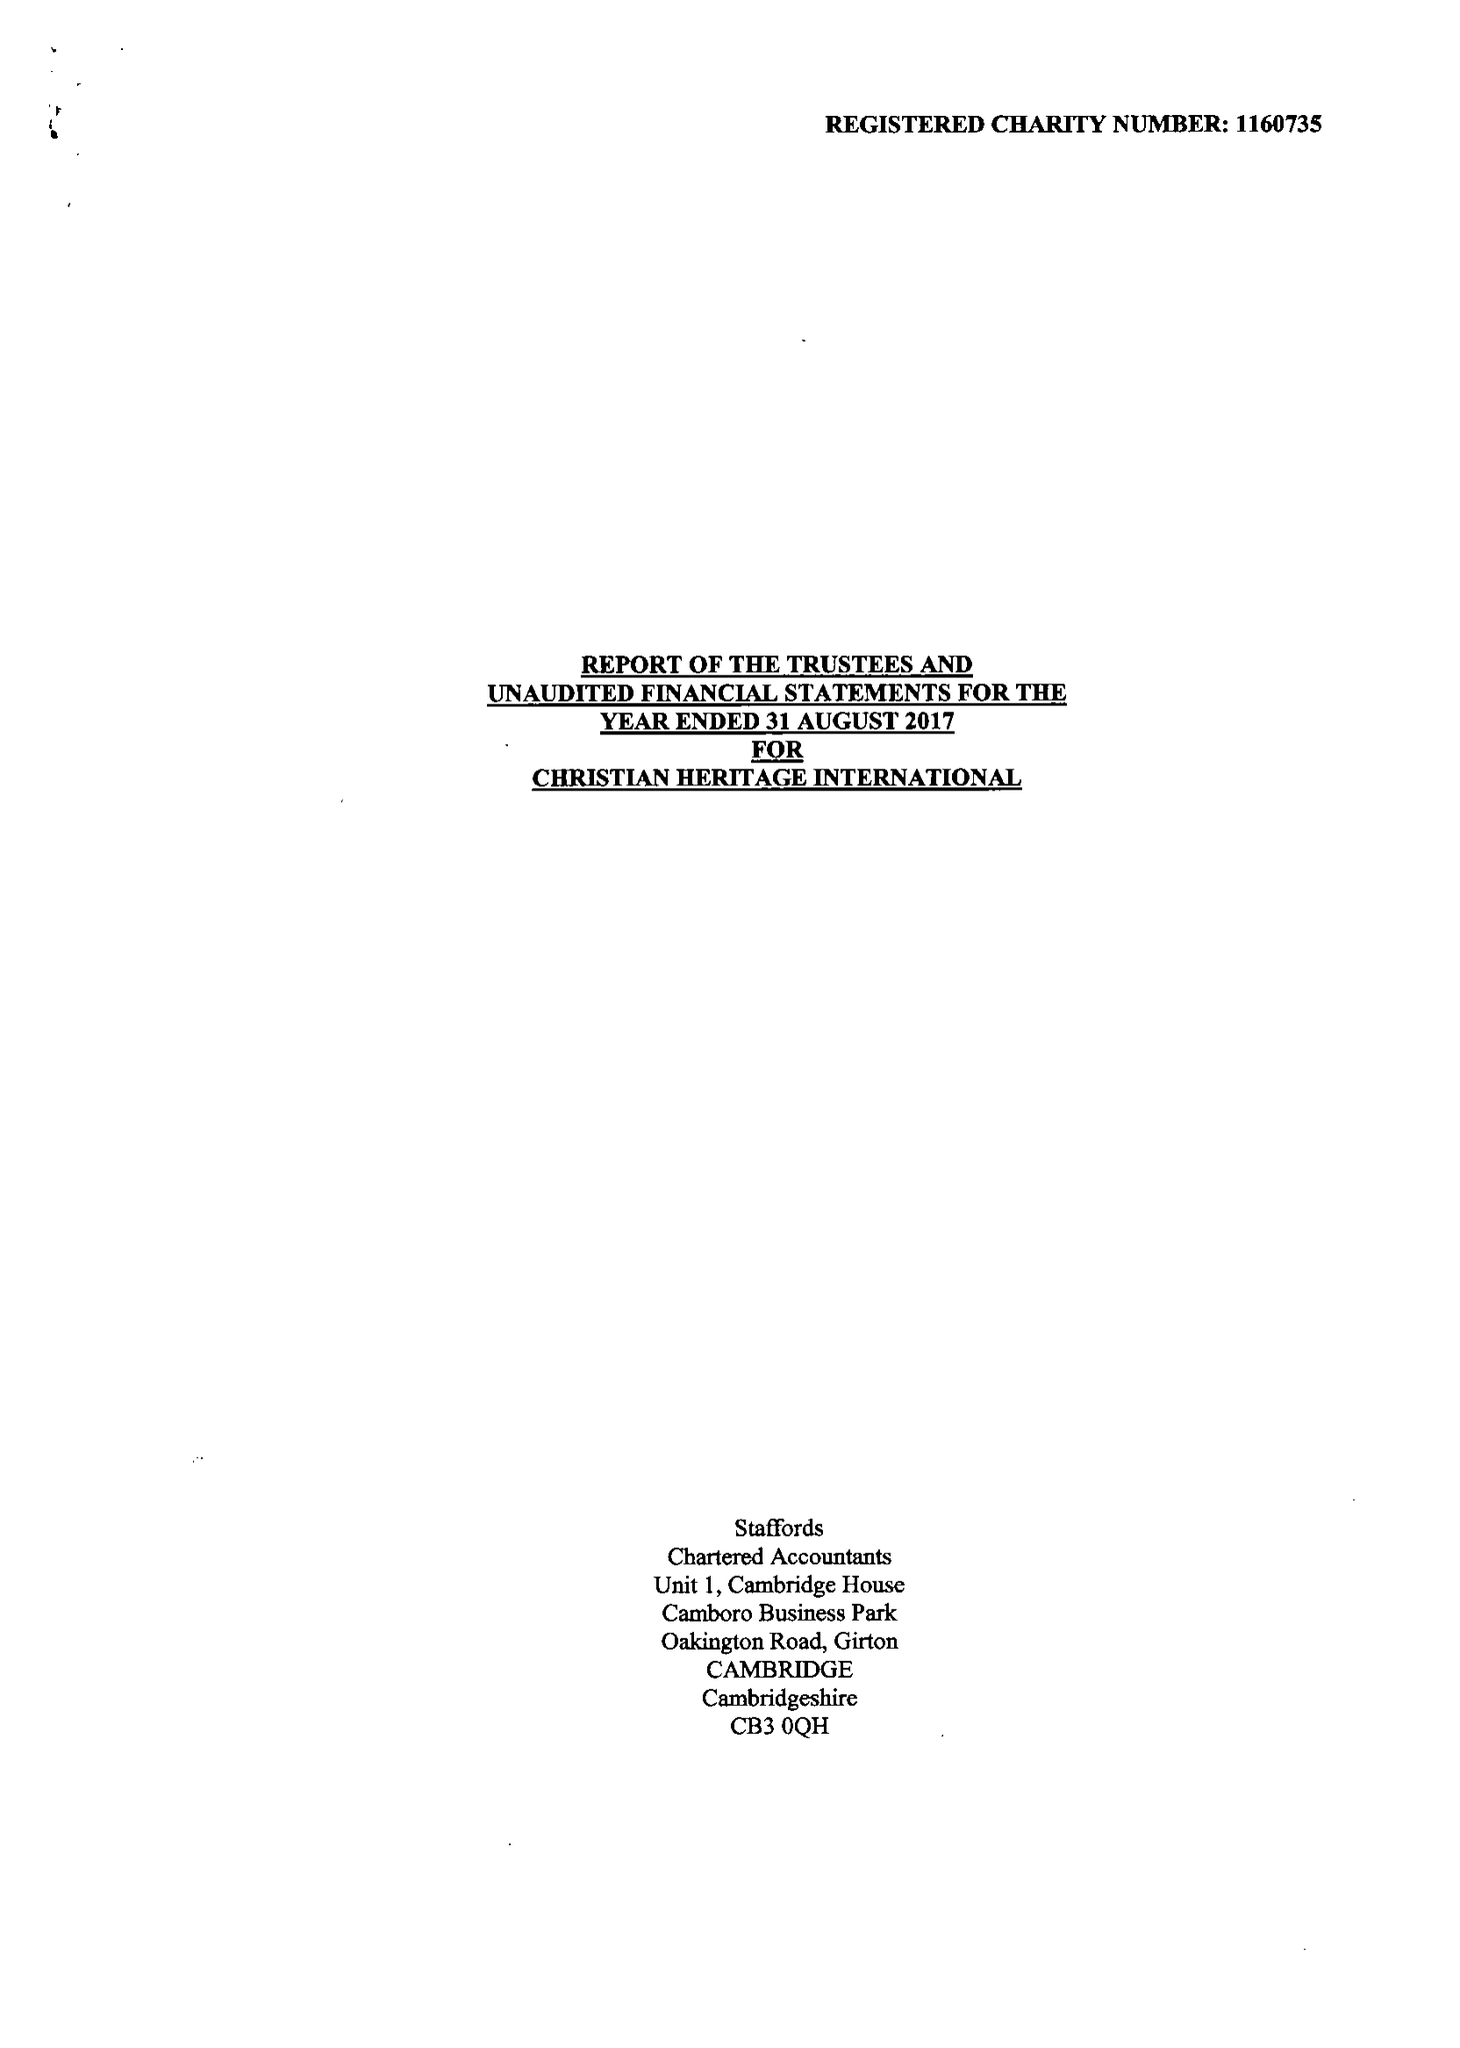What is the value for the income_annually_in_british_pounds?
Answer the question using a single word or phrase. None 